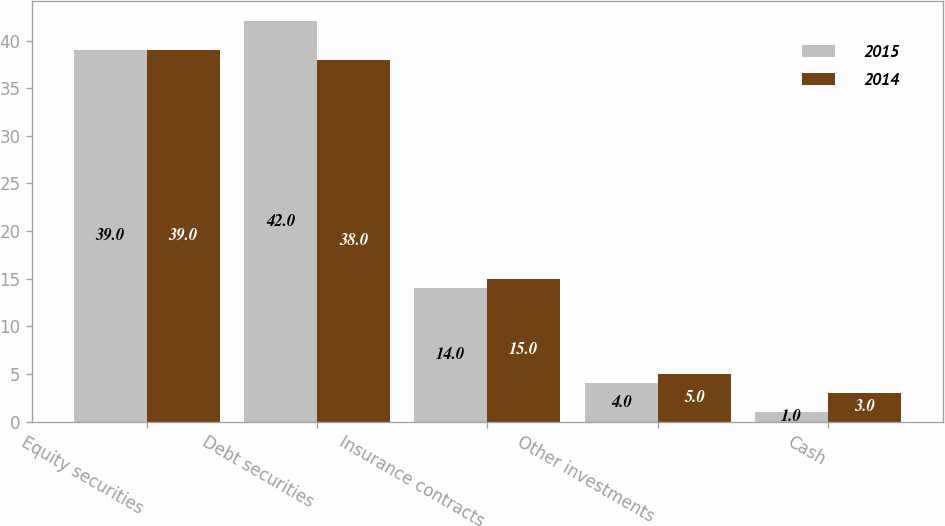<chart> <loc_0><loc_0><loc_500><loc_500><stacked_bar_chart><ecel><fcel>Equity securities<fcel>Debt securities<fcel>Insurance contracts<fcel>Other investments<fcel>Cash<nl><fcel>2015<fcel>39<fcel>42<fcel>14<fcel>4<fcel>1<nl><fcel>2014<fcel>39<fcel>38<fcel>15<fcel>5<fcel>3<nl></chart> 